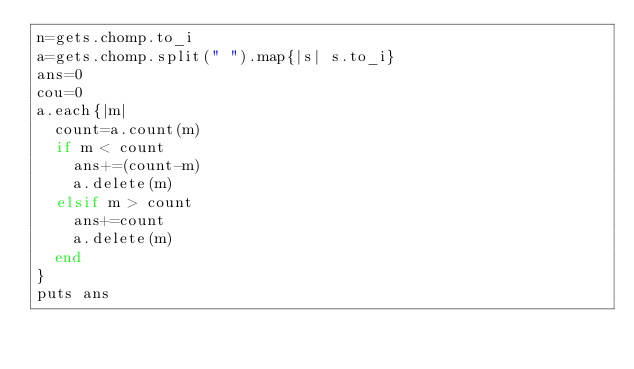<code> <loc_0><loc_0><loc_500><loc_500><_Ruby_>n=gets.chomp.to_i
a=gets.chomp.split(" ").map{|s| s.to_i}
ans=0
cou=0
a.each{|m|
  count=a.count(m)
  if m < count
    ans+=(count-m)
    a.delete(m)
  elsif m > count
    ans+=count
    a.delete(m)
  end
}
puts ans
</code> 